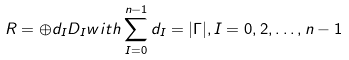<formula> <loc_0><loc_0><loc_500><loc_500>R = \oplus d _ { I } D _ { I } w i t h \sum _ { I = 0 } ^ { n - 1 } d _ { I } = | \Gamma | , I = 0 , 2 , \dots , n - 1</formula> 